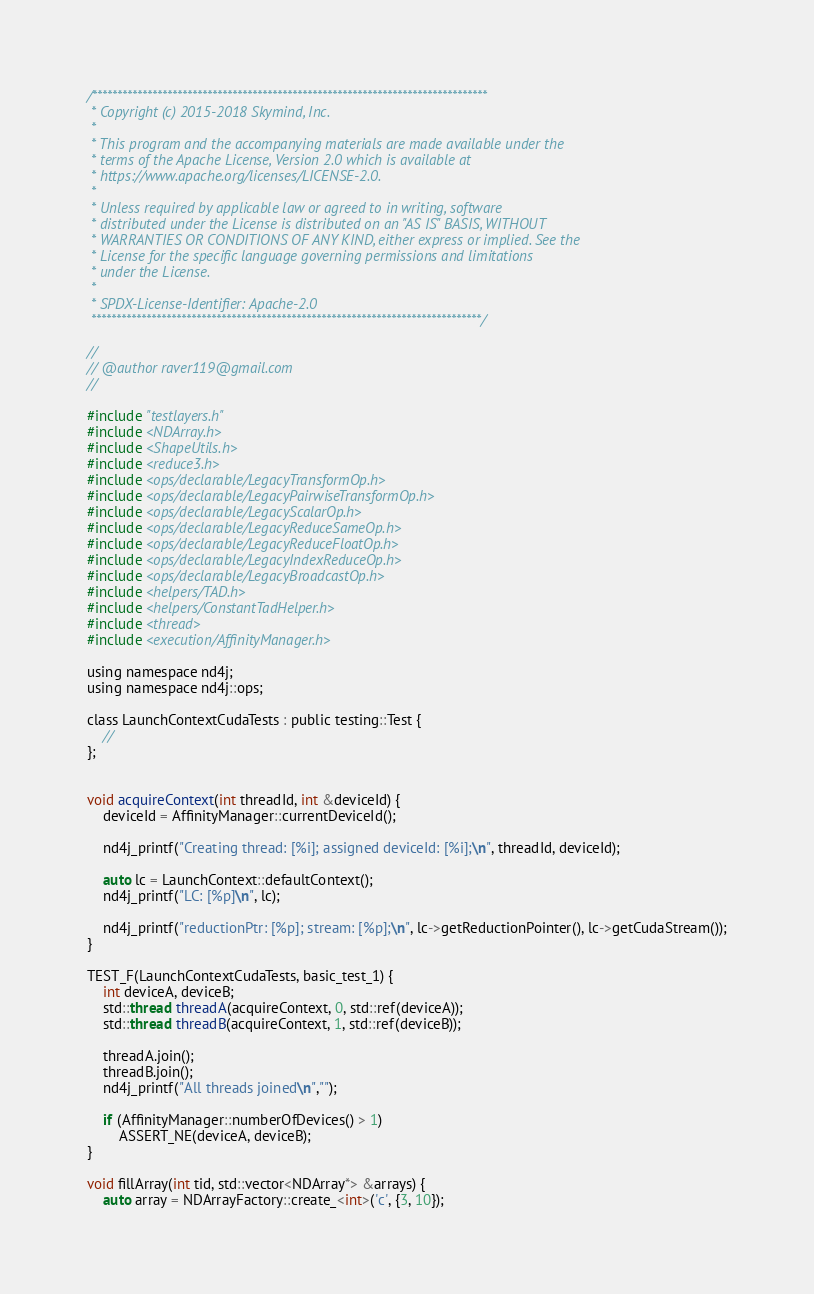<code> <loc_0><loc_0><loc_500><loc_500><_Cuda_>/*******************************************************************************
 * Copyright (c) 2015-2018 Skymind, Inc.
 *
 * This program and the accompanying materials are made available under the
 * terms of the Apache License, Version 2.0 which is available at
 * https://www.apache.org/licenses/LICENSE-2.0.
 *
 * Unless required by applicable law or agreed to in writing, software
 * distributed under the License is distributed on an "AS IS" BASIS, WITHOUT
 * WARRANTIES OR CONDITIONS OF ANY KIND, either express or implied. See the
 * License for the specific language governing permissions and limitations
 * under the License.
 *
 * SPDX-License-Identifier: Apache-2.0
 ******************************************************************************/

//
// @author raver119@gmail.com
//

#include "testlayers.h"
#include <NDArray.h>
#include <ShapeUtils.h>
#include <reduce3.h>
#include <ops/declarable/LegacyTransformOp.h>
#include <ops/declarable/LegacyPairwiseTransformOp.h>
#include <ops/declarable/LegacyScalarOp.h>
#include <ops/declarable/LegacyReduceSameOp.h>
#include <ops/declarable/LegacyReduceFloatOp.h>
#include <ops/declarable/LegacyIndexReduceOp.h>
#include <ops/declarable/LegacyBroadcastOp.h>
#include <helpers/TAD.h>
#include <helpers/ConstantTadHelper.h>
#include <thread>
#include <execution/AffinityManager.h>

using namespace nd4j;
using namespace nd4j::ops;

class LaunchContextCudaTests : public testing::Test {
    //
};


void acquireContext(int threadId, int &deviceId) {
    deviceId = AffinityManager::currentDeviceId();

    nd4j_printf("Creating thread: [%i]; assigned deviceId: [%i];\n", threadId, deviceId);

    auto lc = LaunchContext::defaultContext();
    nd4j_printf("LC: [%p]\n", lc);

    nd4j_printf("reductionPtr: [%p]; stream: [%p];\n", lc->getReductionPointer(), lc->getCudaStream());
}

TEST_F(LaunchContextCudaTests, basic_test_1) {
    int deviceA, deviceB;
    std::thread threadA(acquireContext, 0, std::ref(deviceA));
    std::thread threadB(acquireContext, 1, std::ref(deviceB));

    threadA.join();
    threadB.join();
    nd4j_printf("All threads joined\n","");

    if (AffinityManager::numberOfDevices() > 1)
        ASSERT_NE(deviceA, deviceB);
}

void fillArray(int tid, std::vector<NDArray*> &arrays) {
    auto array = NDArrayFactory::create_<int>('c', {3, 10});</code> 